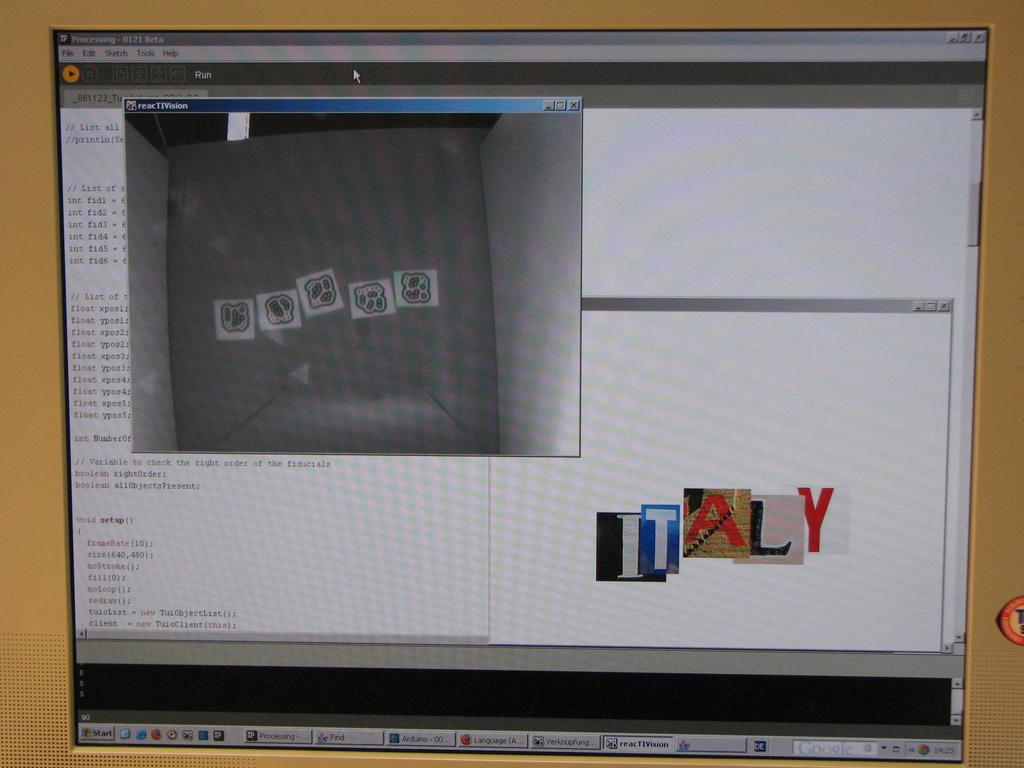<image>
Summarize the visual content of the image. a computer monitor with word ITALY on it 